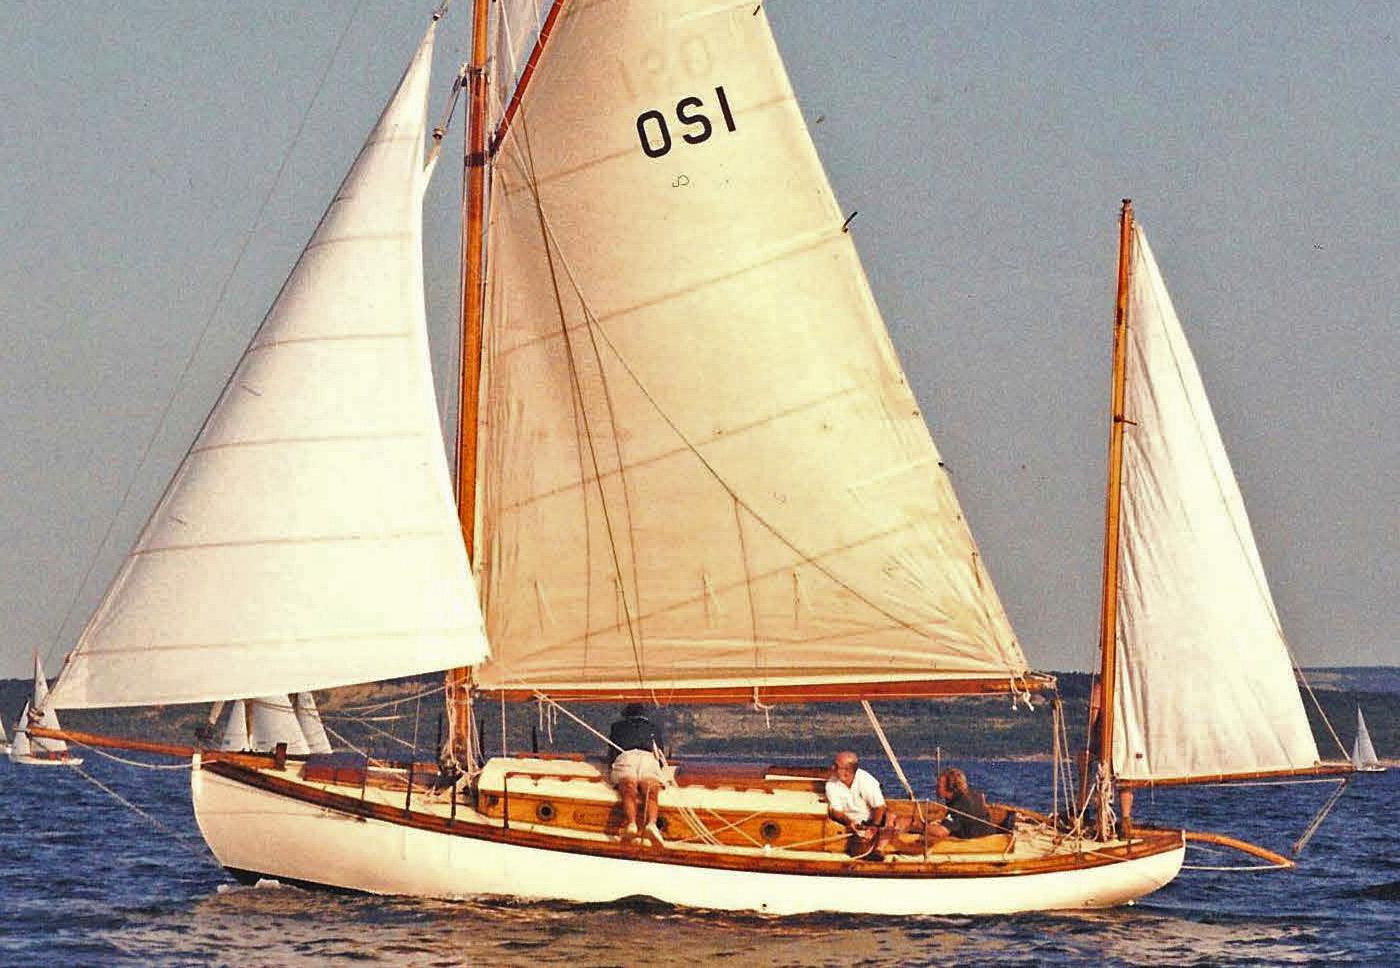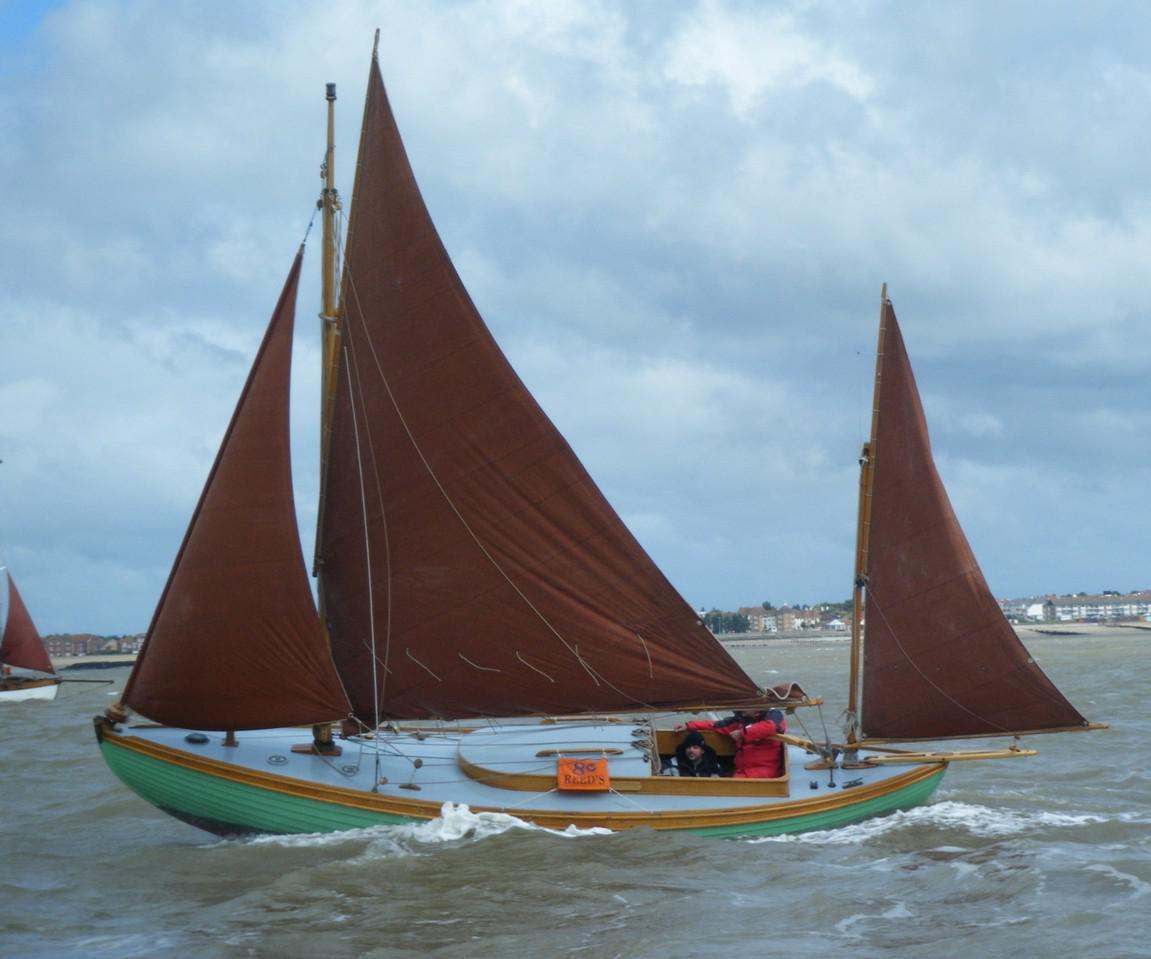The first image is the image on the left, the second image is the image on the right. Examine the images to the left and right. Is the description "One image shows a boat with a green exterior and brown sails." accurate? Answer yes or no. Yes. The first image is the image on the left, the second image is the image on the right. Evaluate the accuracy of this statement regarding the images: "In one of the images the boat is blue.". Is it true? Answer yes or no. Yes. 